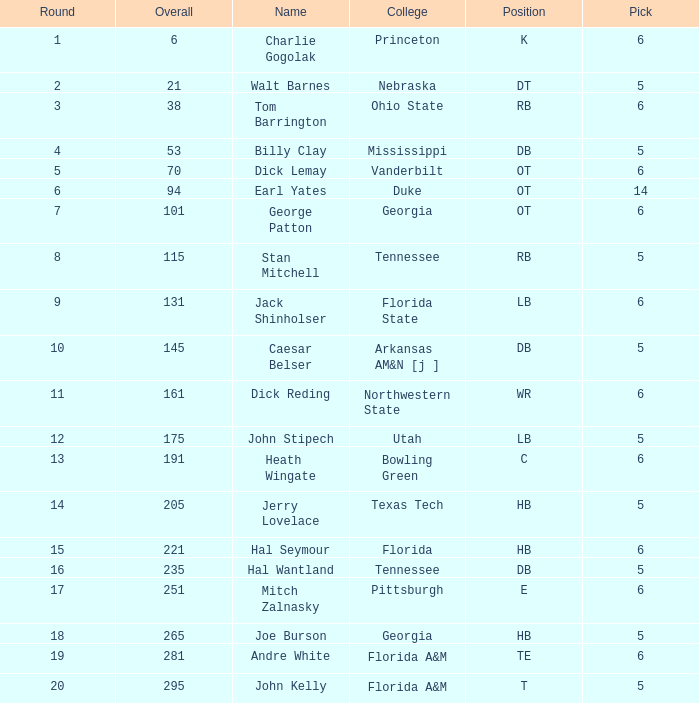What is the highest Pick, when Round is greater than 15, and when College is "Tennessee"? 5.0. 